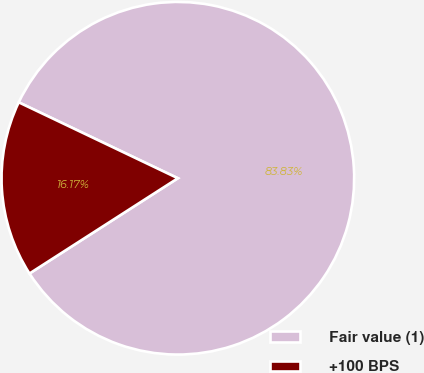Convert chart. <chart><loc_0><loc_0><loc_500><loc_500><pie_chart><fcel>Fair value (1)<fcel>+100 BPS<nl><fcel>83.83%<fcel>16.17%<nl></chart> 